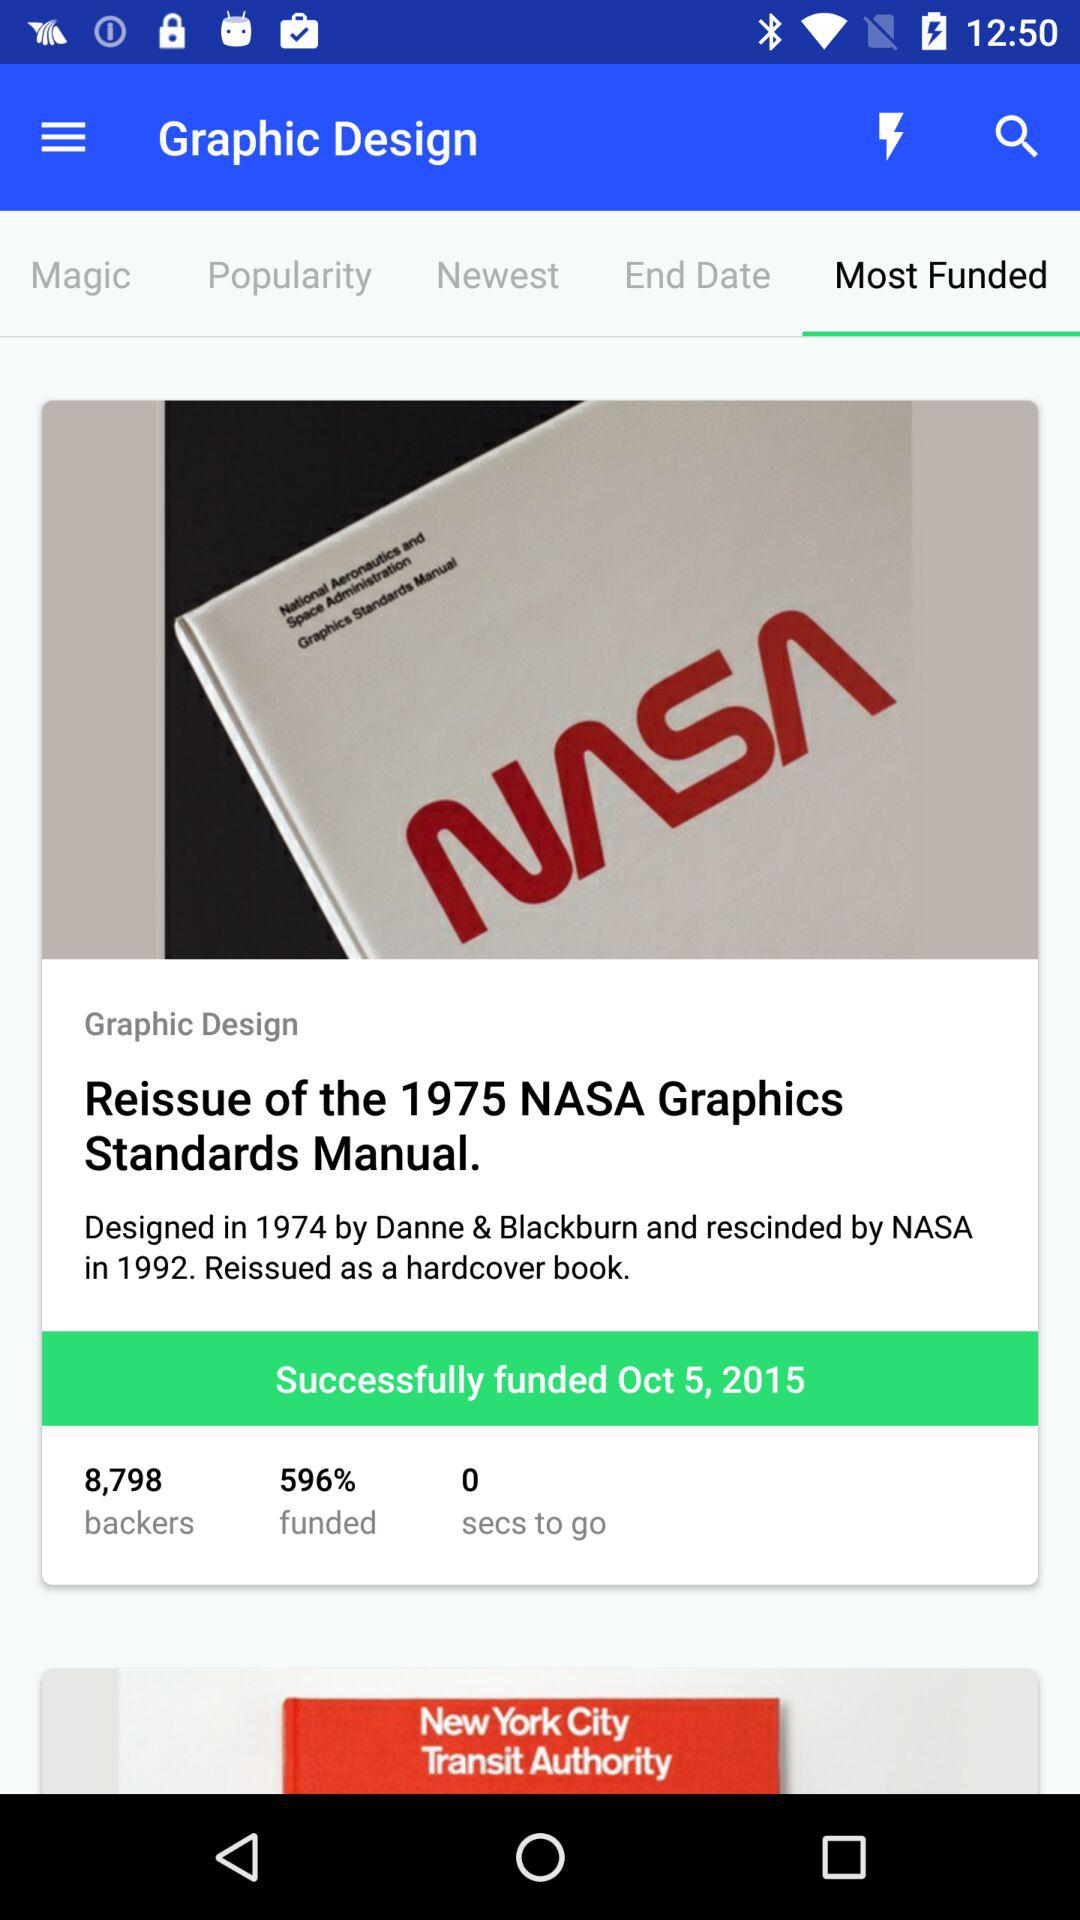What is the funded year? The funded year is 2015. 